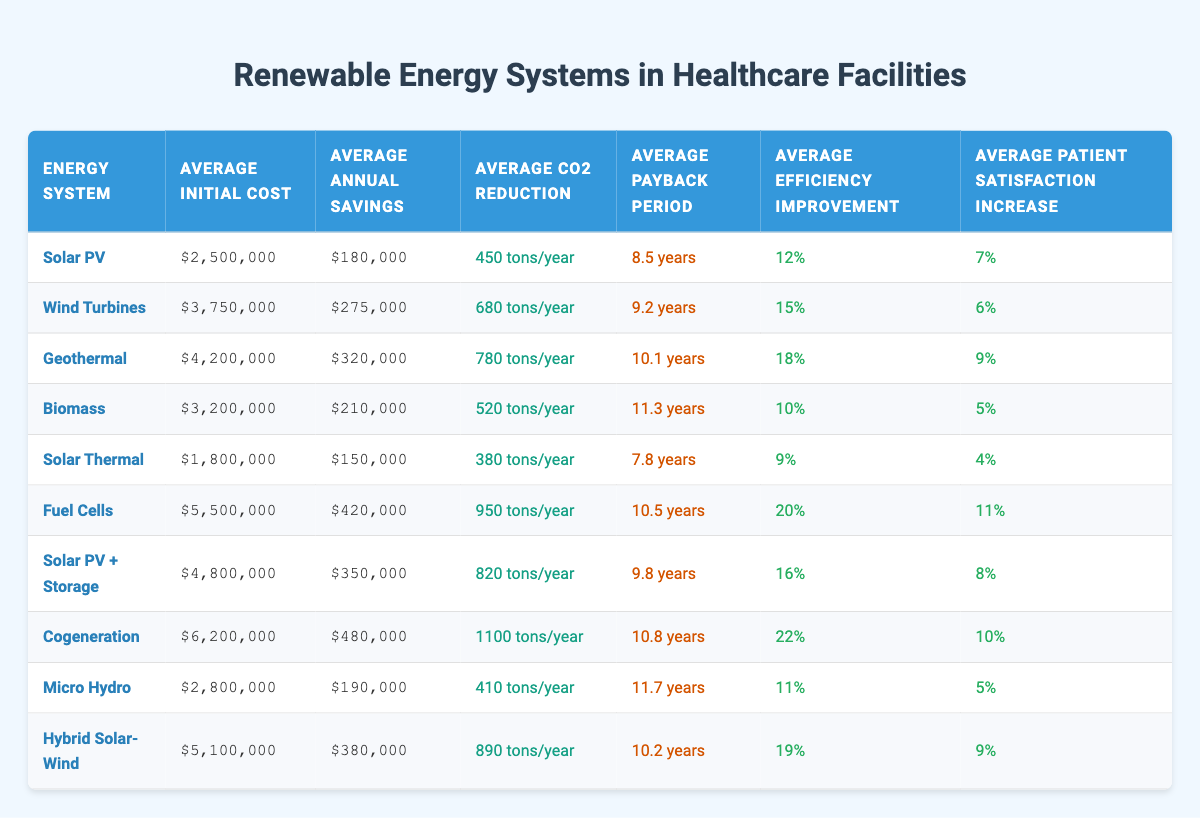What is the average initial cost of Solar PV systems? The initial cost for Solar PV is listed in the table as $2,500,000. Since there is only one entry for this energy system, the average is the same as the single value.
Answer: $2,500,000 Which energy system has the highest annual energy savings? Looking through the table, Fuel Cells have the highest annual energy savings at $420,000 compared to the other systems.
Answer: Fuel Cells What is the total CO2 reduction for Wind Turbines and Solar Thermal combined? The CO2 reduction for Wind Turbines is 680 tons/year and for Solar Thermal is 380 tons/year. Adding these together gives 680 + 380 = 1060 tons/year.
Answer: 1060 tons/year Is the payback period for Cogeneration shorter than 10 years? The payback period for Cogeneration is 10.8 years, which is longer than 10 years. Therefore, the answer is no.
Answer: No Which energy system offers the greatest improvement in operational efficiency? By examining the efficiencies listed, Cogeneration has the highest improvement at 22%. This is greater than all the other energy systems in the table.
Answer: Cogeneration What is the average payback period for renewable energy systems in healthcare facilities? To find the average, sum all the payback periods (8.5 + 9.2 + 10.1 + 11.3 + 7.8 + 10.5 + 9.8 + 10.8 + 11.7 + 10.2 = 109.9 years) and divide by the total number of systems (10). The average is 109.9 / 10 = 10.99 years.
Answer: 10.99 years Did UCSF Medical Center experience more than a 5% increase in patient satisfaction? The patient satisfaction increase for UCSF Medical Center is 4%, which is not greater than 5%. Therefore, the answer is no.
Answer: No What is the difference in annual energy savings between Johns Hopkins Hospital and Massachusetts General Hospital? Johns Hopkins Hospital saves $320,000 annually, while Massachusetts General Hospital saves $210,000 annually. The difference is 320,000 - 210,000 = 110,000.
Answer: $110,000 Which facility qualified for the least amount of CO2 reduction? Examining the CO2 reduction values, Micro Hydro has the least reduction at 410 tons/year, lower than all other systems.
Answer: Micro Hydro 